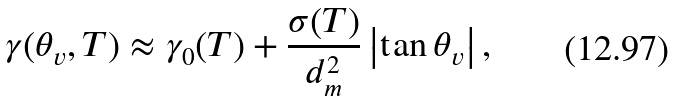Convert formula to latex. <formula><loc_0><loc_0><loc_500><loc_500>\gamma ( \theta _ { v } , T ) \approx \gamma _ { 0 } ( T ) + \frac { \sigma ( T ) } { d _ { m } ^ { 2 } } \left | \tan \theta _ { v } \right | ,</formula> 